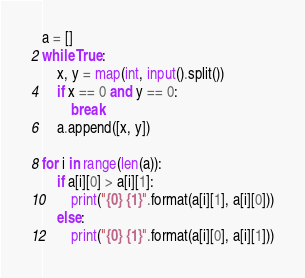Convert code to text. <code><loc_0><loc_0><loc_500><loc_500><_Python_>a = []
while True:
    x, y = map(int, input().split())
    if x == 0 and y == 0:
        break
    a.append([x, y])

for i in range(len(a)):
    if a[i][0] > a[i][1]:
        print("{0} {1}".format(a[i][1], a[i][0]))
    else:
        print("{0} {1}".format(a[i][0], a[i][1]))

</code> 